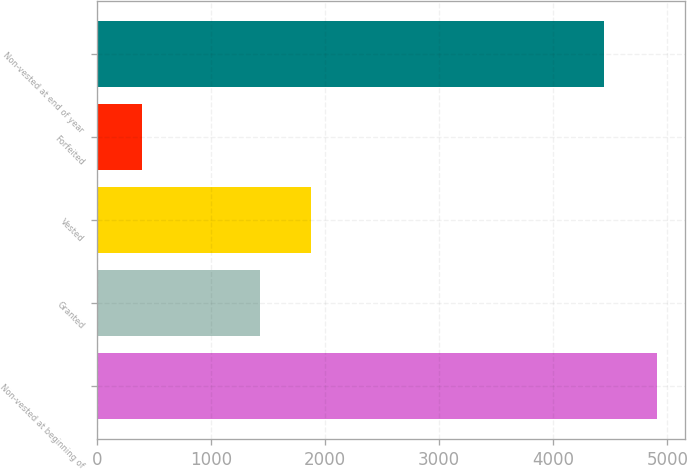Convert chart. <chart><loc_0><loc_0><loc_500><loc_500><bar_chart><fcel>Non-vested at beginning of<fcel>Granted<fcel>Vested<fcel>Forfeited<fcel>Non-vested at end of year<nl><fcel>4913<fcel>1425<fcel>1876.5<fcel>398<fcel>4444<nl></chart> 